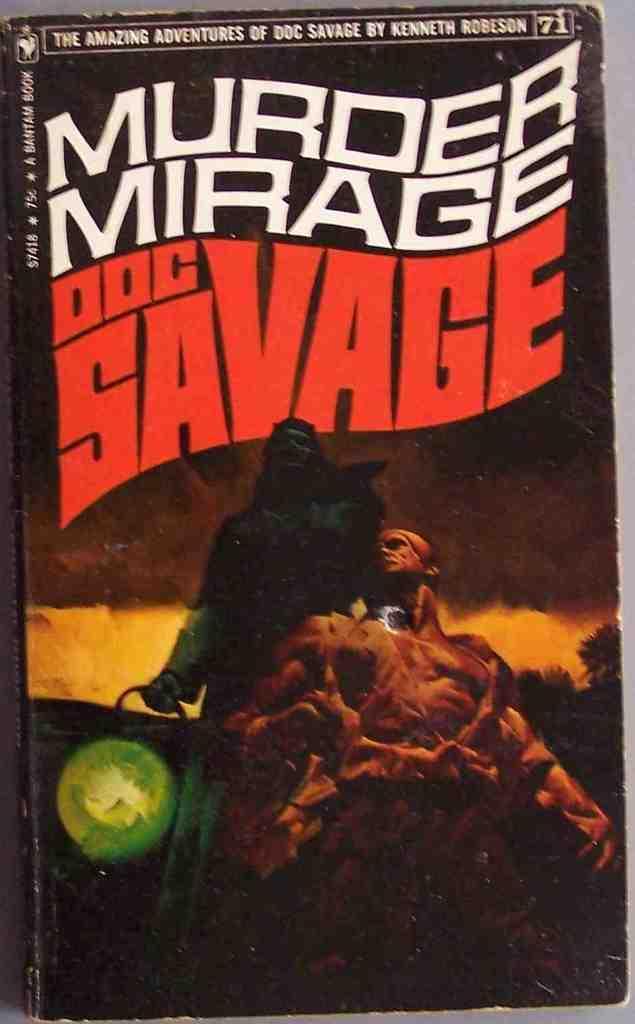In one or two sentences, can you explain what this image depicts? In this image I can see the cover page of book which is black in color on which I can see two persons standing, the sky, few trees and few words written. I can see a green colored object. 